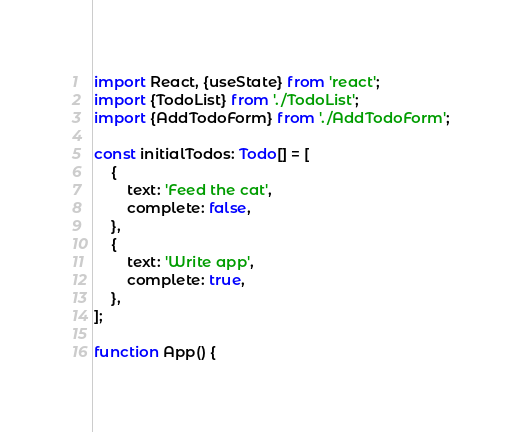Convert code to text. <code><loc_0><loc_0><loc_500><loc_500><_TypeScript_>import React, {useState} from 'react';
import {TodoList} from './TodoList';
import {AddTodoForm} from './AddTodoForm';

const initialTodos: Todo[] = [
    {
        text: 'Feed the cat',
        complete: false,
    },
    {
        text: 'Write app',
        complete: true,
    },
];

function App() {</code> 